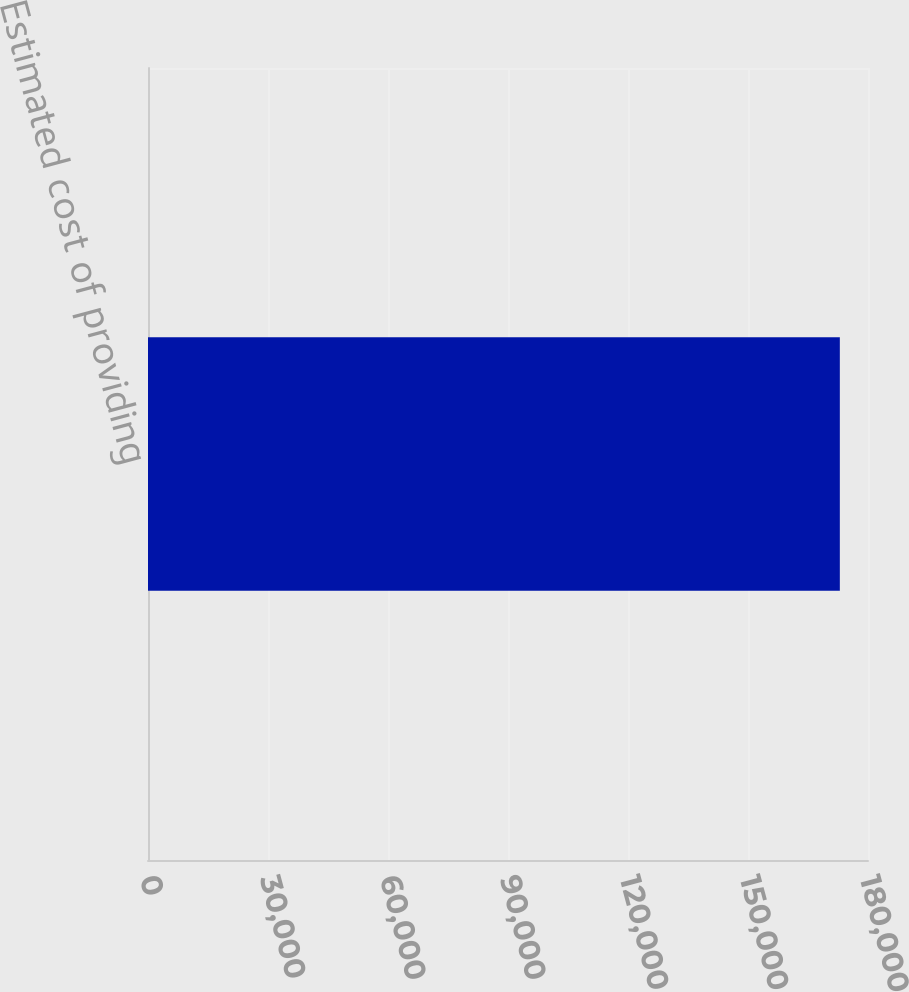<chart> <loc_0><loc_0><loc_500><loc_500><bar_chart><fcel>Estimated cost of providing<nl><fcel>172959<nl></chart> 